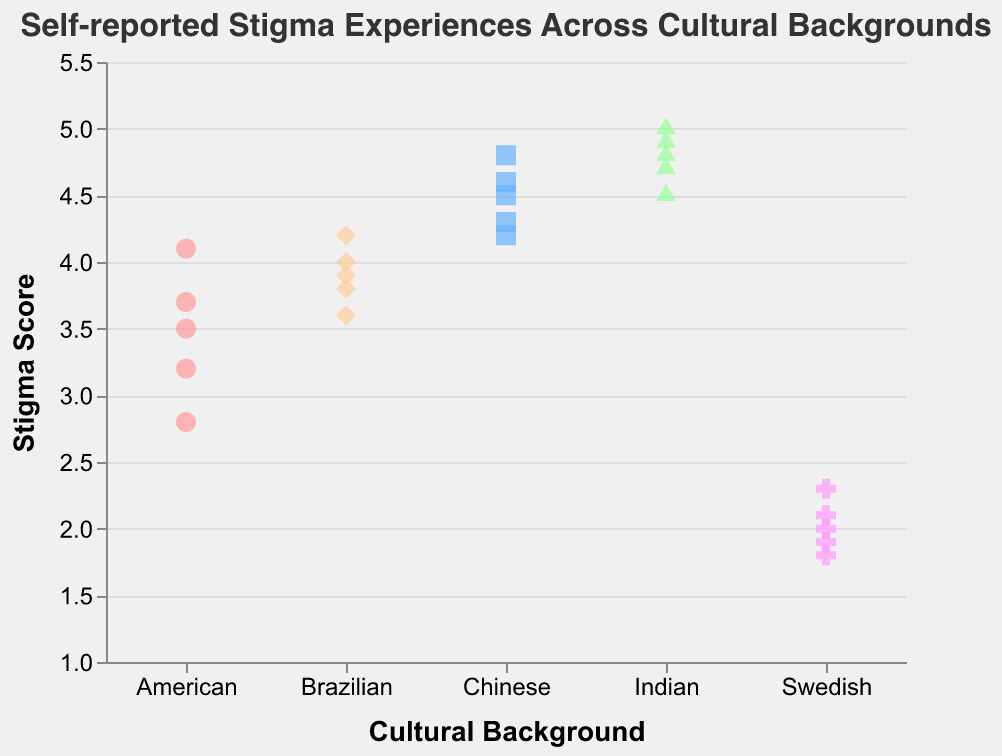How many cultural backgrounds are included in the figure? Identify the different categories represented on the x-axis.
Answer: Five What is the highest stigma score reported among Swedish women? Look at the vertical range of the points associated with "Swedish" and find the maximum value.
Answer: 2.3 Which cultural background has the lowest stigma scores overall? Compare the range of stigma scores for each cultural background and identify the one with the lowest values.
Answer: Swedish What is the range of stigma scores reported by American women? Find the minimum and maximum stigma scores reported by American women. The range is the difference between these values.
Answer: 2.8 to 4.1 Which cultural background has the highest median stigma score? Order the stigma scores for each cultural background and find the median value for comparison.
Answer: Indian How many data points are there for each cultural background? Count the number of points for each cultural background on the chart. This may involve multiple steps of counting.
Answer: Five per group Which two cultural backgrounds have the closest median stigma scores? Calculate or identify the median stigma score for each cultural background and compare them to find the closest pair.
Answer: Chinese and Indian What shape represents the stigma scores of Brazilian women on the strip plot? Look at the legend and identify which shape corresponds to the "Brazilian" cultural background.
Answer: Diamond What is the average stigma score for Chinese women? Sum the stigma scores for the Chinese women and divide by the number of scores. 4.5 + 4.8 + 4.2 + 4.6 + 4.3 = 22.4; then 22.4 / 5 = 4.48.
Answer: 4.48 How do the stigma scores of American women compare to those of Brazilian women? Compare the range and spread of stigma scores for American and Brazilian women by observing their distributions on the plot.
Answer: American scores are slightly lower overall 